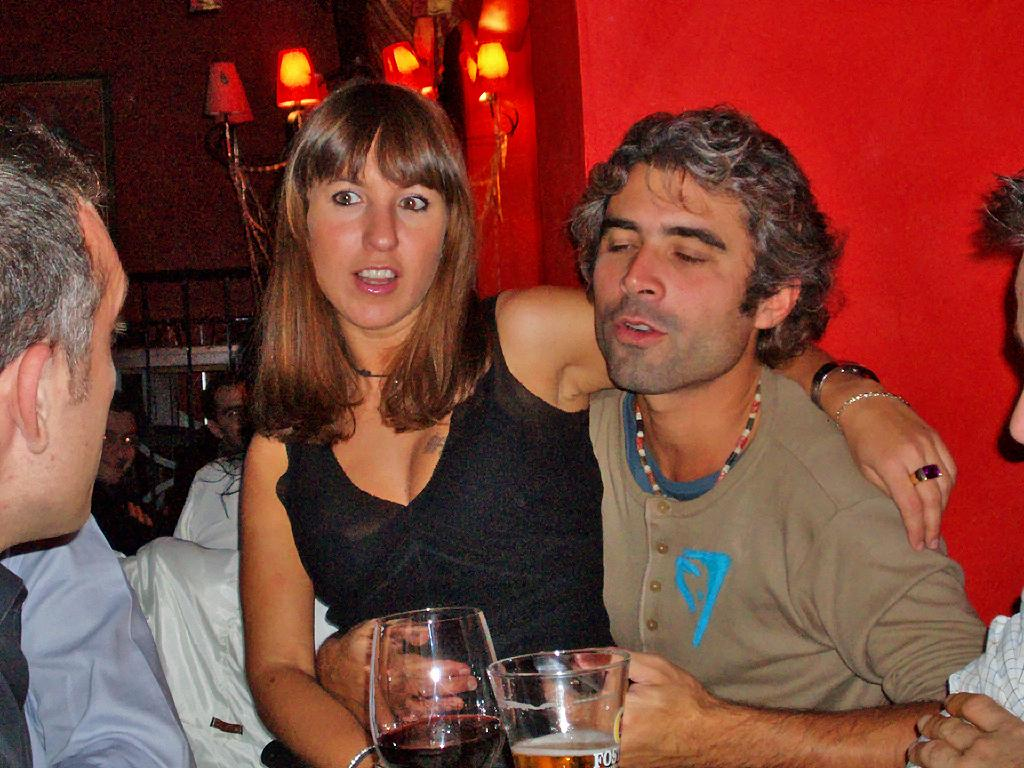What can be seen in the background of the image? There is a wall and lights visible in the background of the image. What is the person in the image doing? The person sitting in the image is a man and a woman, and they are both holding drinking glasses. What are the man and woman holding in the image? The man is holding a drinking glass, and the woman is also holding a drinking glass. What type of wax is being used by the secretary in the image? There is no secretary or wax present in the image. What sign can be seen in the image? There is no sign visible in the image. 